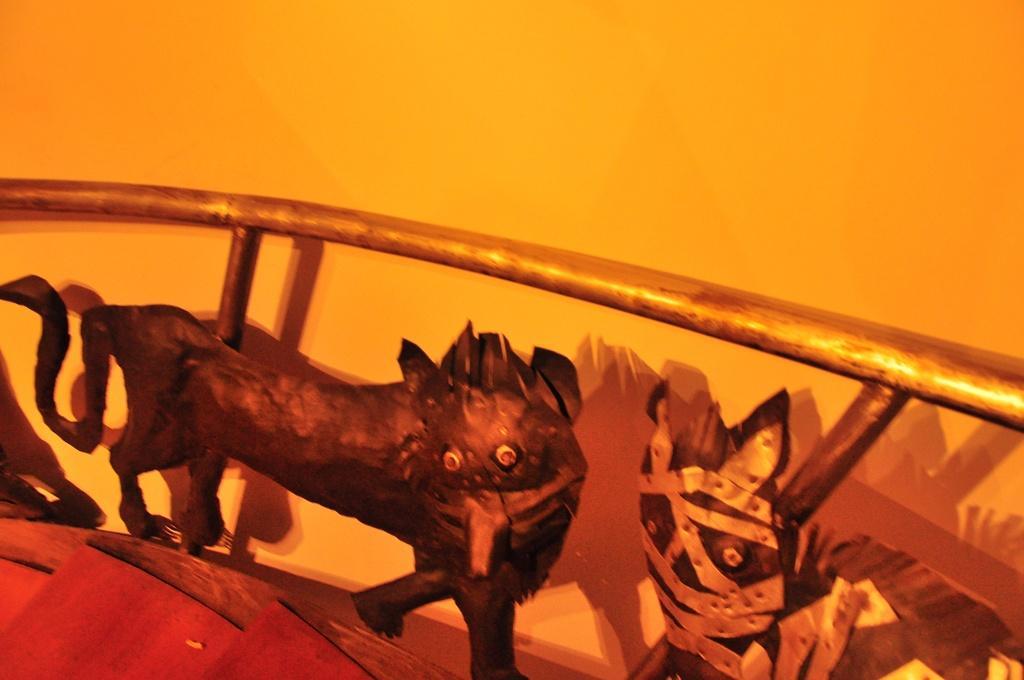Could you give a brief overview of what you see in this image? In this picture I can see wooden stairs and I can see few animal paintings fixed to the metal rods and a wall on the side. 